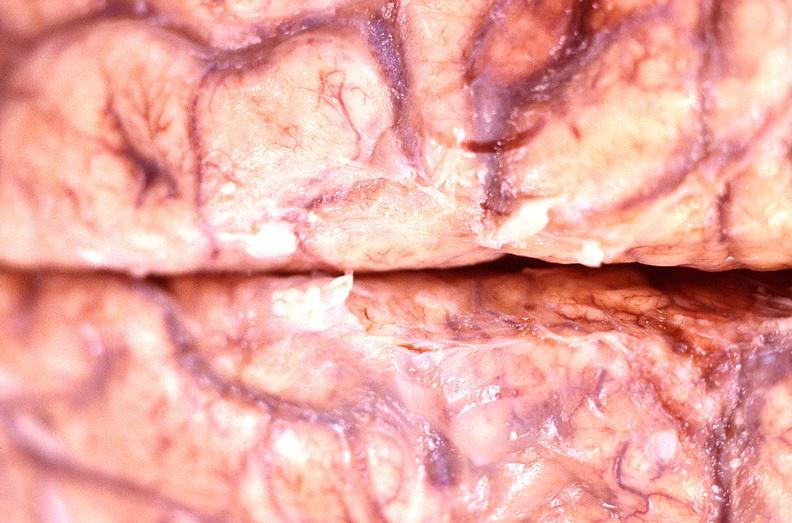s surface present?
Answer the question using a single word or phrase. No 